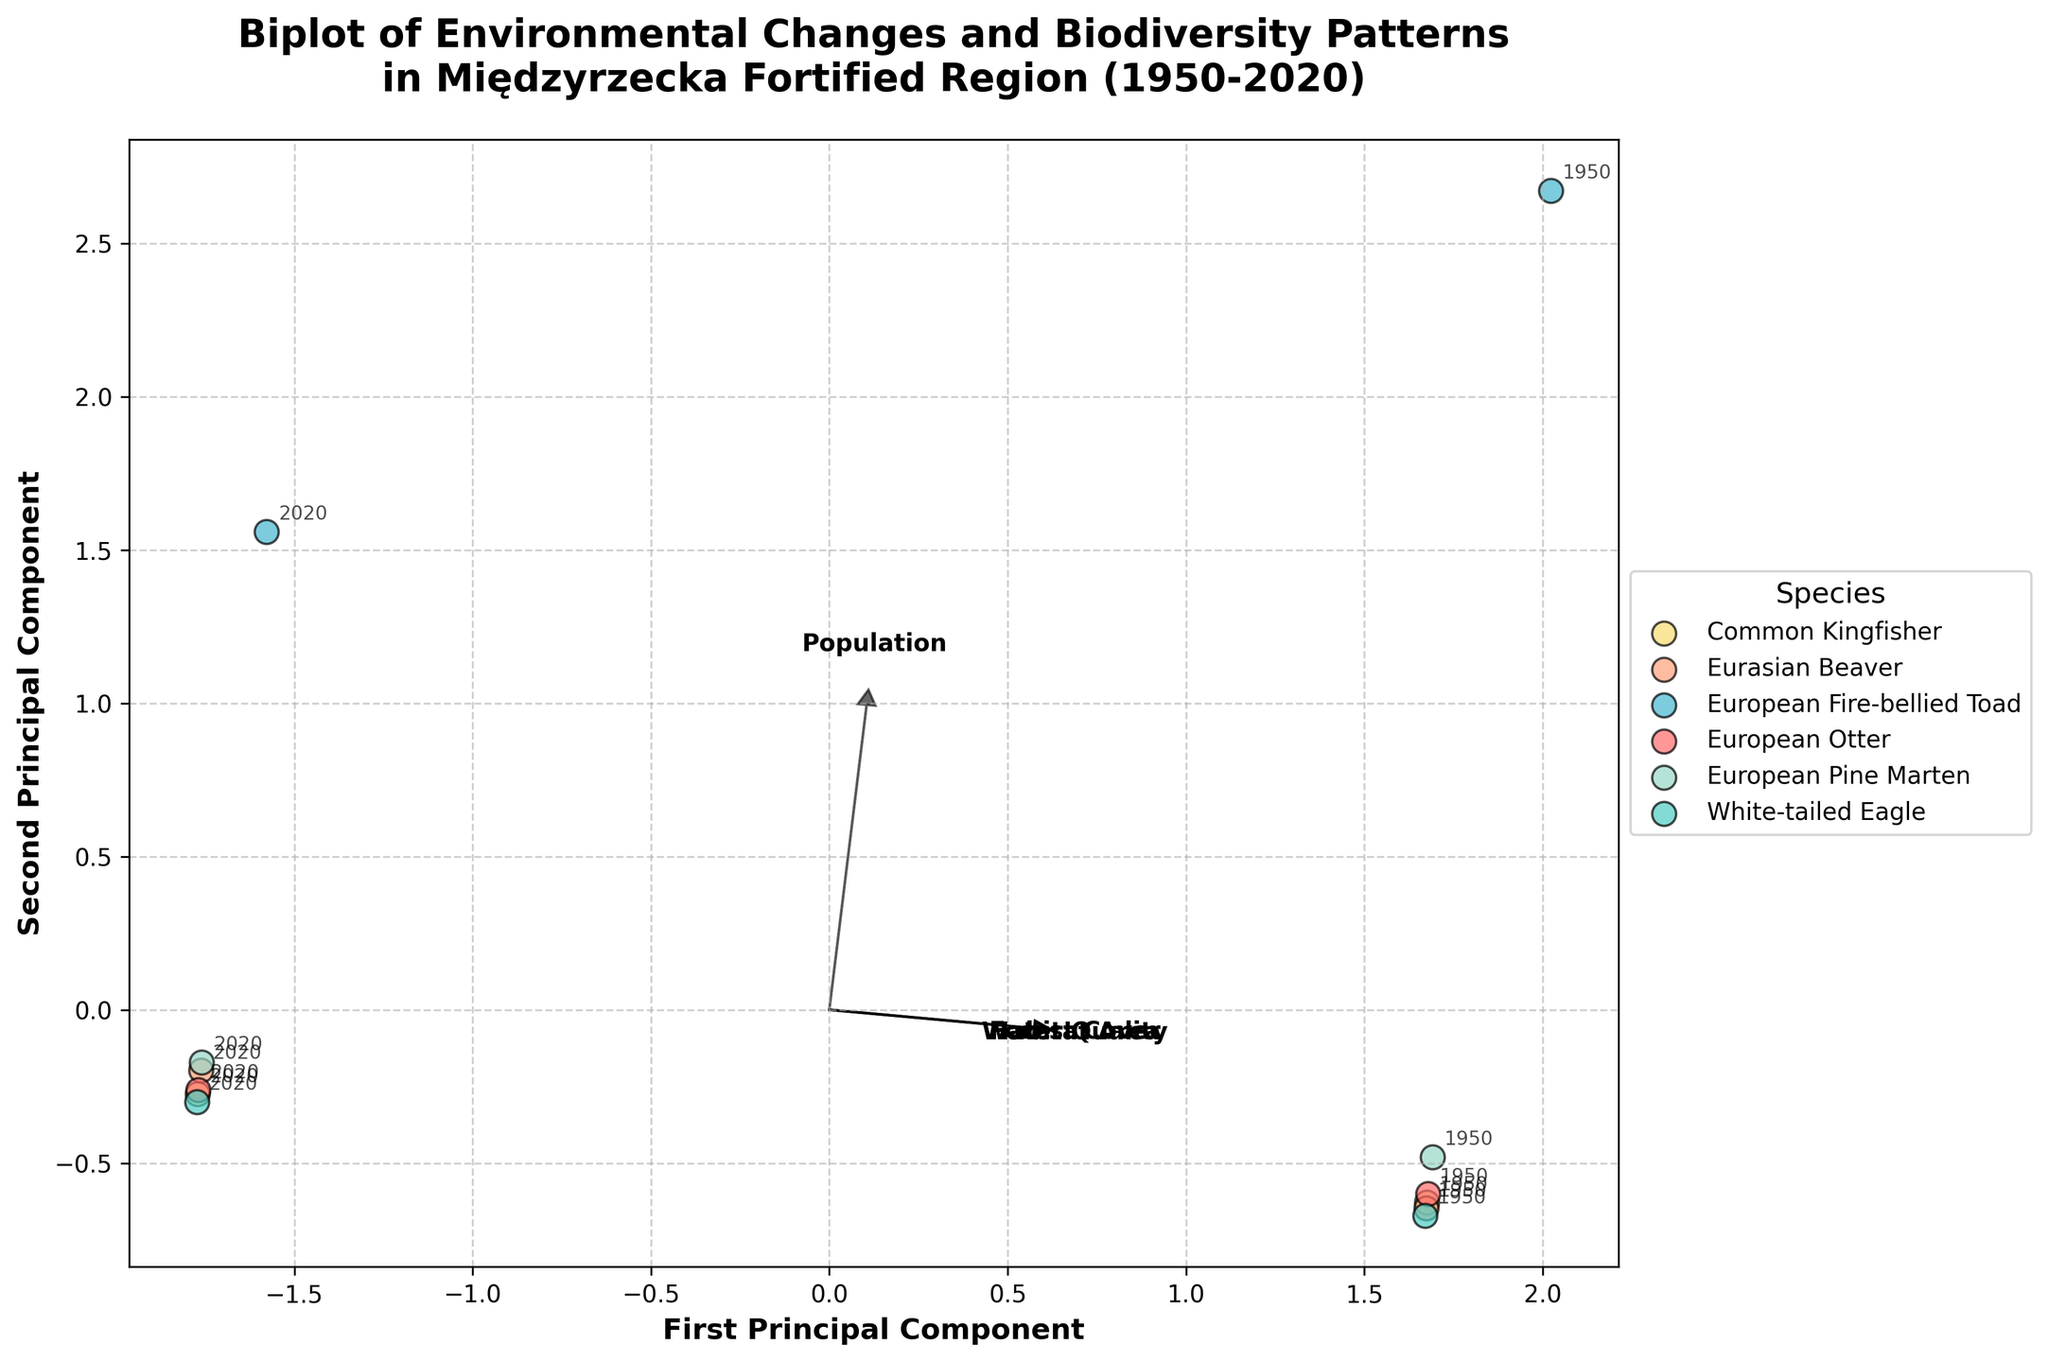what is the title of the plot? The title is the text located at the upper part of the plot, indicating its content. It reads "Biplot of Environmental Changes and Biodiversity Patterns in Międzyrzecka Fortified Region (1950-2020)."
Answer: Biplot of Environmental Changes and Biodiversity Patterns in Międzyrzecka Fortified Region (1950-2020) Which species has the highest population in 2020? Look at the data points labeled with the year 2020 and check the species with the highest position along the Population feature vector. The species with the highest value in the Population feature is "Eurasian Beaver."
Answer: Eurasian Beaver How did the population of the European Fire-bellied Toad change from 1950 to 2020? Compare the European Fire-bellied Toad's population change from 1950 to 2020 by locating data points for the specified years and the species. The population decreased from 5000 to 2800.
Answer: Decreased from 5000 to 2800 Which features are most strongly correlated with the first principal component? The correlation between features and the first principal component is represented by the arrows pointing in the direction with the largest spread on the horizontal axis. Population and Habitat Area features have the longest arrows in this direction.
Answer: Population and Habitat Area In which direction does the Forest Cover feature vector point? Locate the arrow labeled "Forest Cover" extending from the origin (0,0). It points towards the lower right quadrant of the plot.
Answer: Lower right quadrant What pattern is observed in water quality from 1950 to 2020 for different species? Examine the position of the arrows and the labeled years. All data points move towards a lower value on the Water Quality feature vector from 1950 to 2020, indicating a decrease.
Answer: Decrease in water quality Which species shows an increase in population from 1950 to 2020? Check the data points for 1950 and 2020 and compare the populations. The White-tailed Eagle and Eurasian Beaver show an increase.
Answer: White-tailed Eagle and Eurasian Beaver How does the habitat area change affect species distribution in the biplot? Look at how the data points shift along the Habitat Area feature vector. Most species show a reduction in habitat area as their points move in the direction of the vector from 1950 to 2020.
Answer: Reduction in habitat area What trend is observed in forest cover from 1950 to 2020 for all species? Identify the arrows and the positions labeled with the years. All species points move towards a lower value on the Forest Cover feature vector, indicating a decrease in forest cover.
Answer: Decrease in forest cover 